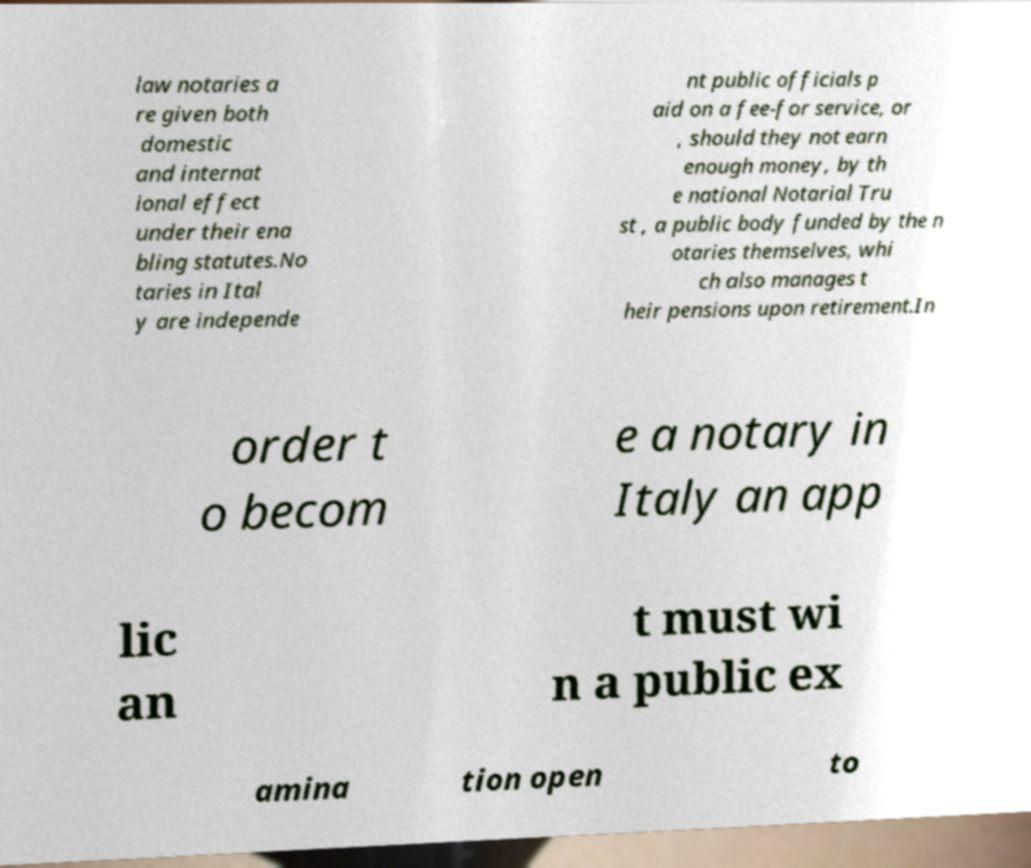Could you extract and type out the text from this image? law notaries a re given both domestic and internat ional effect under their ena bling statutes.No taries in Ital y are independe nt public officials p aid on a fee-for service, or , should they not earn enough money, by th e national Notarial Tru st , a public body funded by the n otaries themselves, whi ch also manages t heir pensions upon retirement.In order t o becom e a notary in Italy an app lic an t must wi n a public ex amina tion open to 